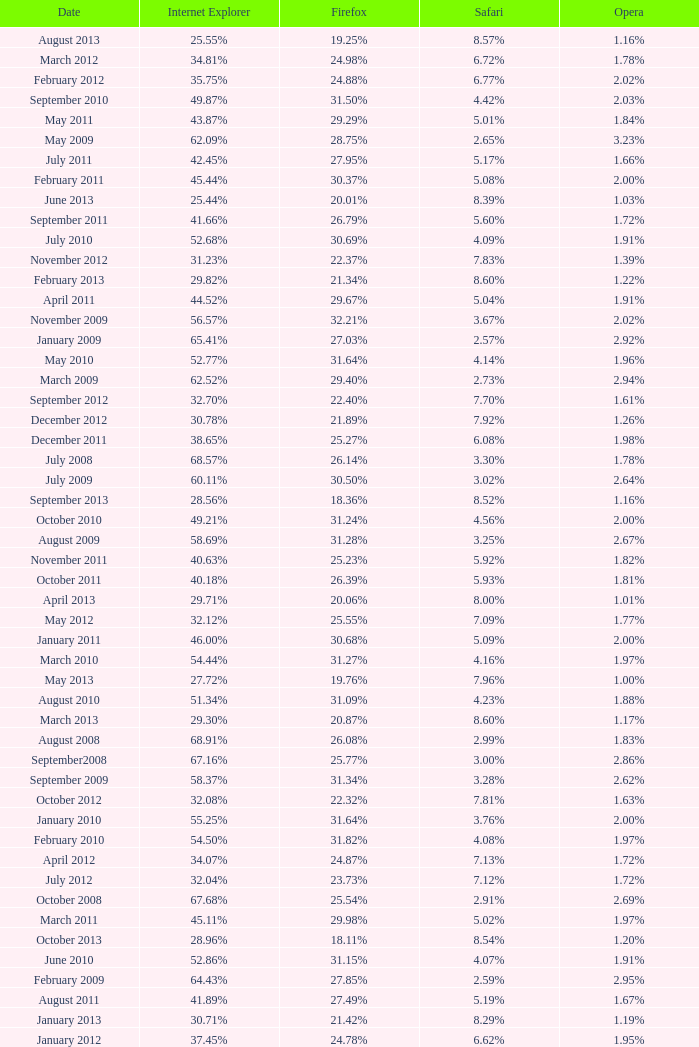What percentage of browsers were using Opera in November 2009? 2.02%. 